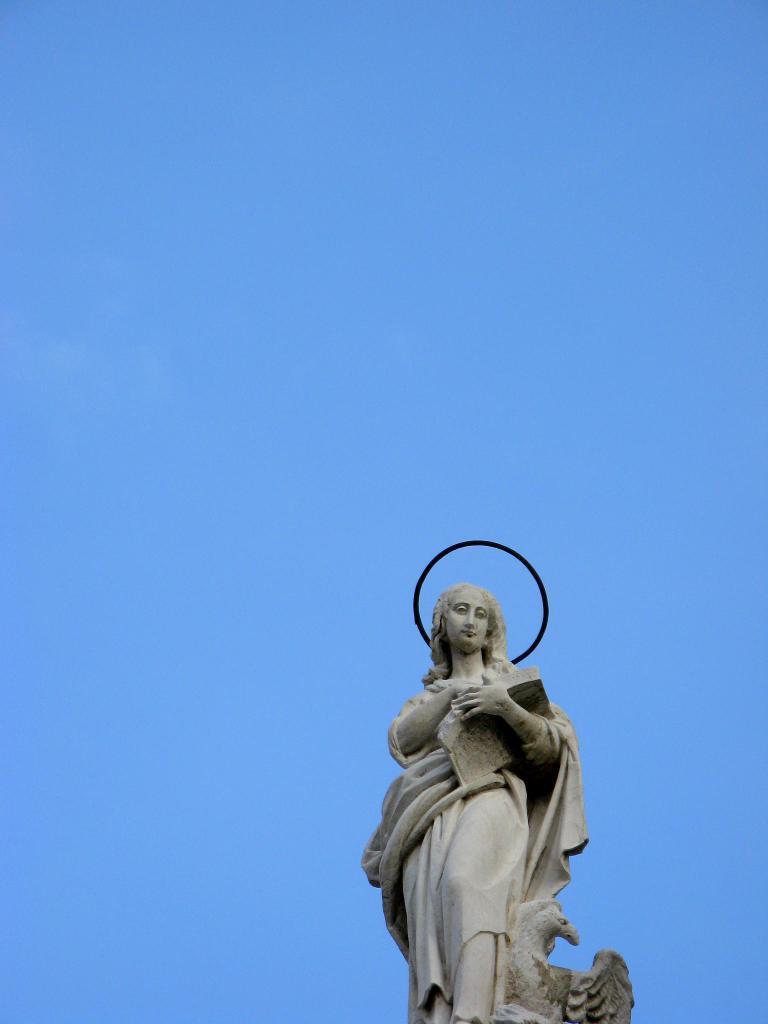How would you summarize this image in a sentence or two? In the image there is a sculpture of a woman. 